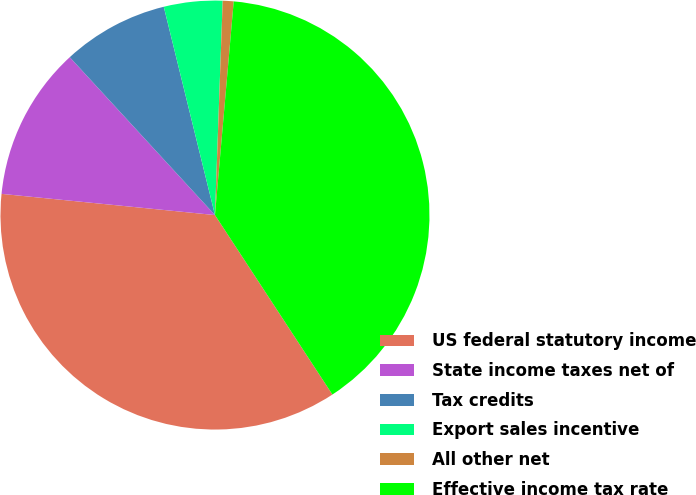Convert chart. <chart><loc_0><loc_0><loc_500><loc_500><pie_chart><fcel>US federal statutory income<fcel>State income taxes net of<fcel>Tax credits<fcel>Export sales incentive<fcel>All other net<fcel>Effective income tax rate<nl><fcel>35.8%<fcel>11.59%<fcel>8.0%<fcel>4.41%<fcel>0.82%<fcel>39.39%<nl></chart> 